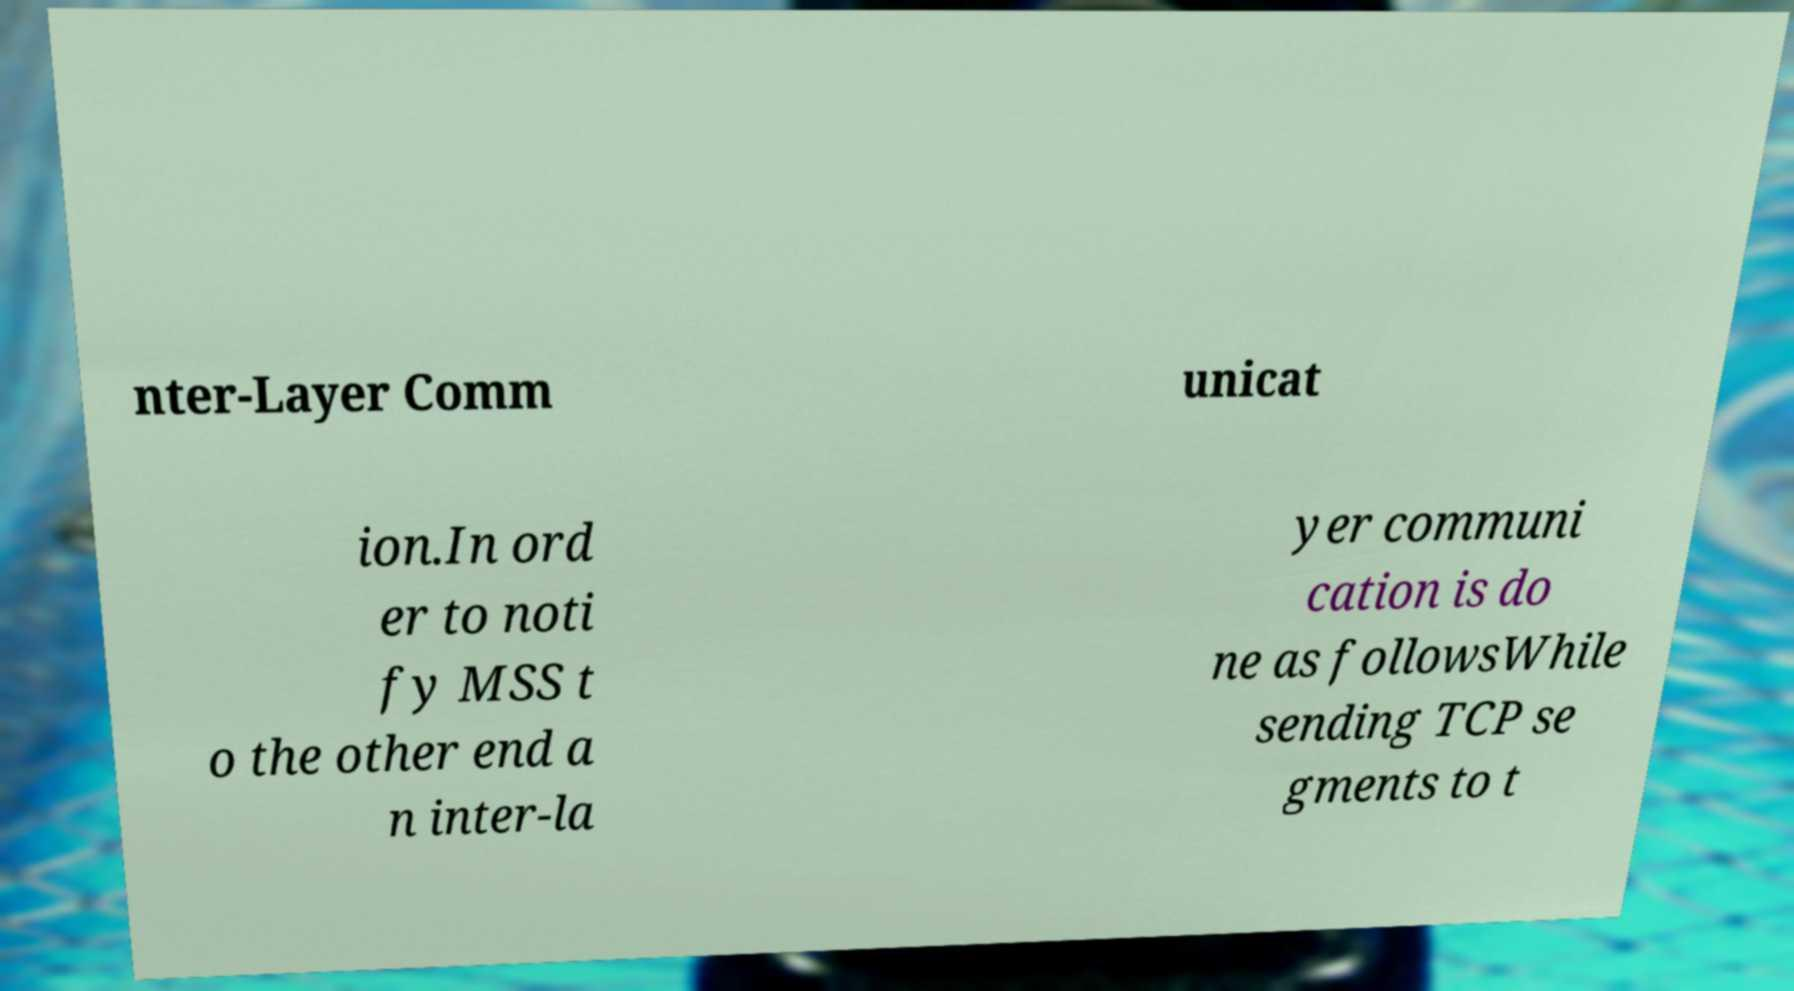Could you assist in decoding the text presented in this image and type it out clearly? nter-Layer Comm unicat ion.In ord er to noti fy MSS t o the other end a n inter-la yer communi cation is do ne as followsWhile sending TCP se gments to t 